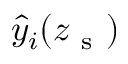<formula> <loc_0><loc_0><loc_500><loc_500>\hat { y } _ { i } ( z _ { s } )</formula> 